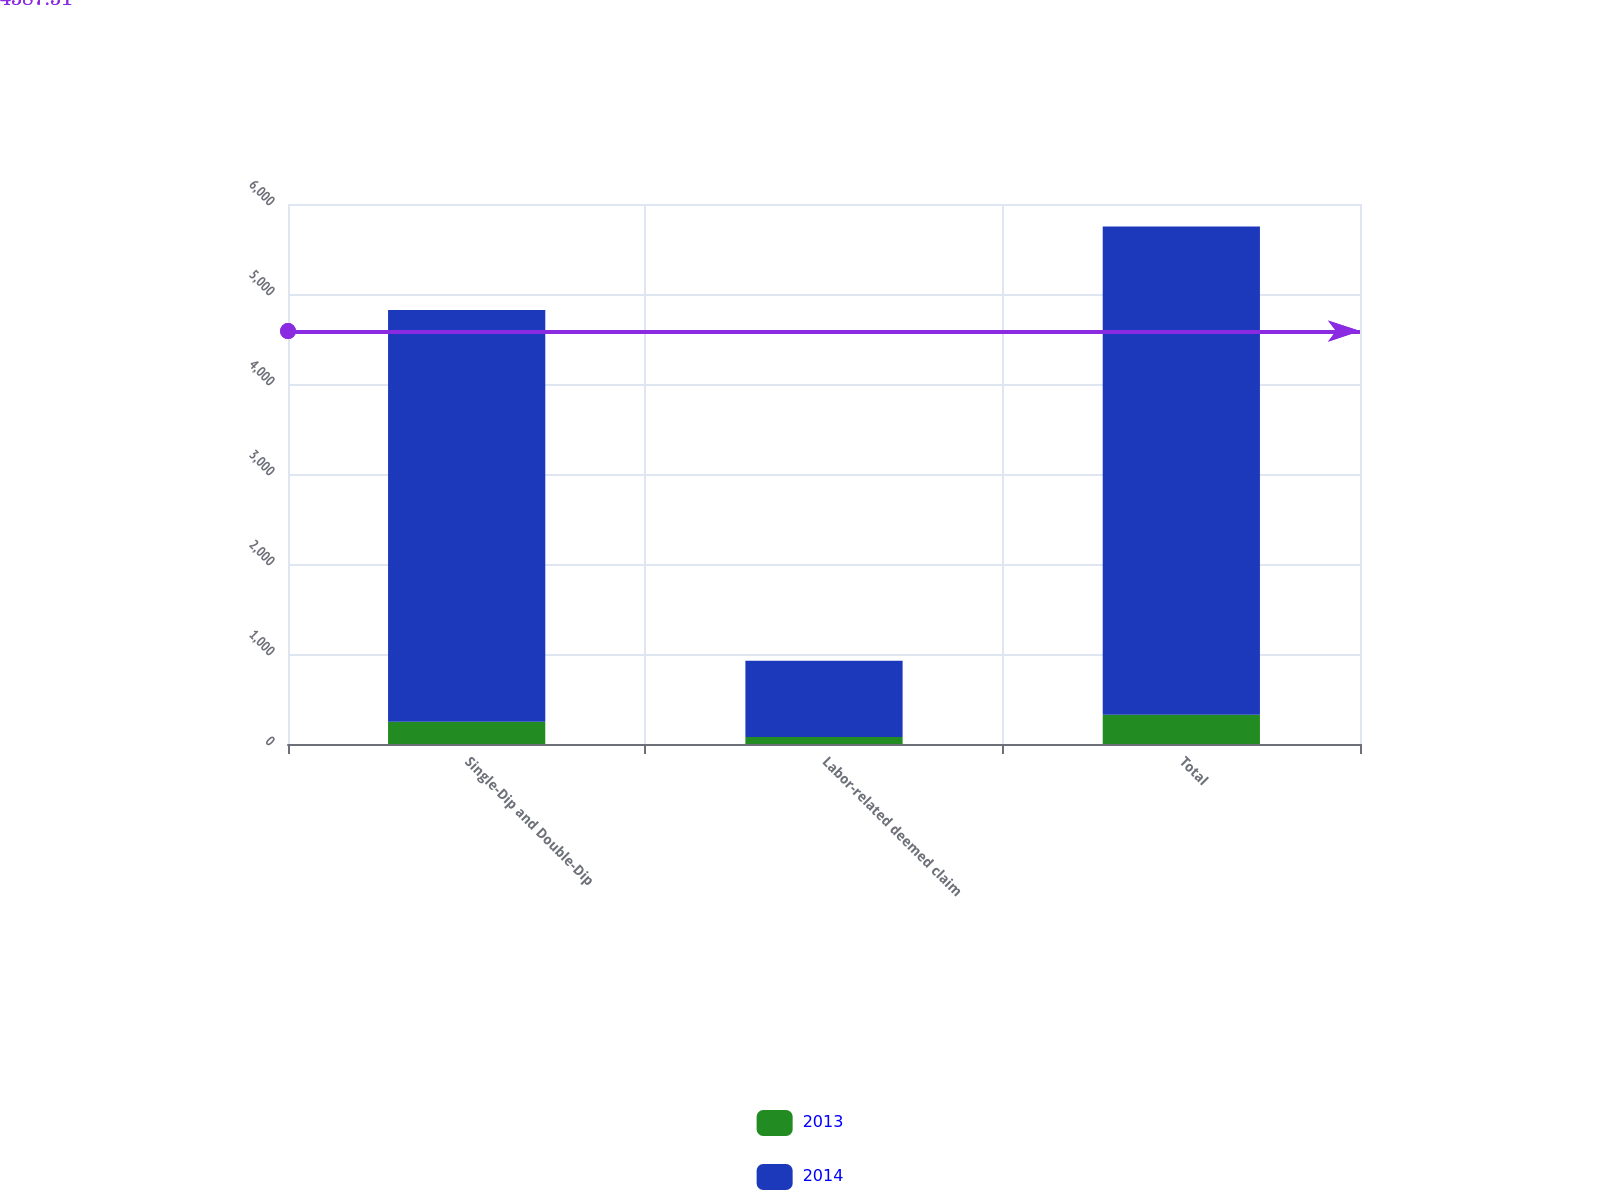<chart> <loc_0><loc_0><loc_500><loc_500><stacked_bar_chart><ecel><fcel>Single-Dip and Double-Dip<fcel>Labor-related deemed claim<fcel>Total<nl><fcel>2013<fcel>248<fcel>77<fcel>325<nl><fcel>2014<fcel>4575<fcel>849<fcel>5424<nl></chart> 